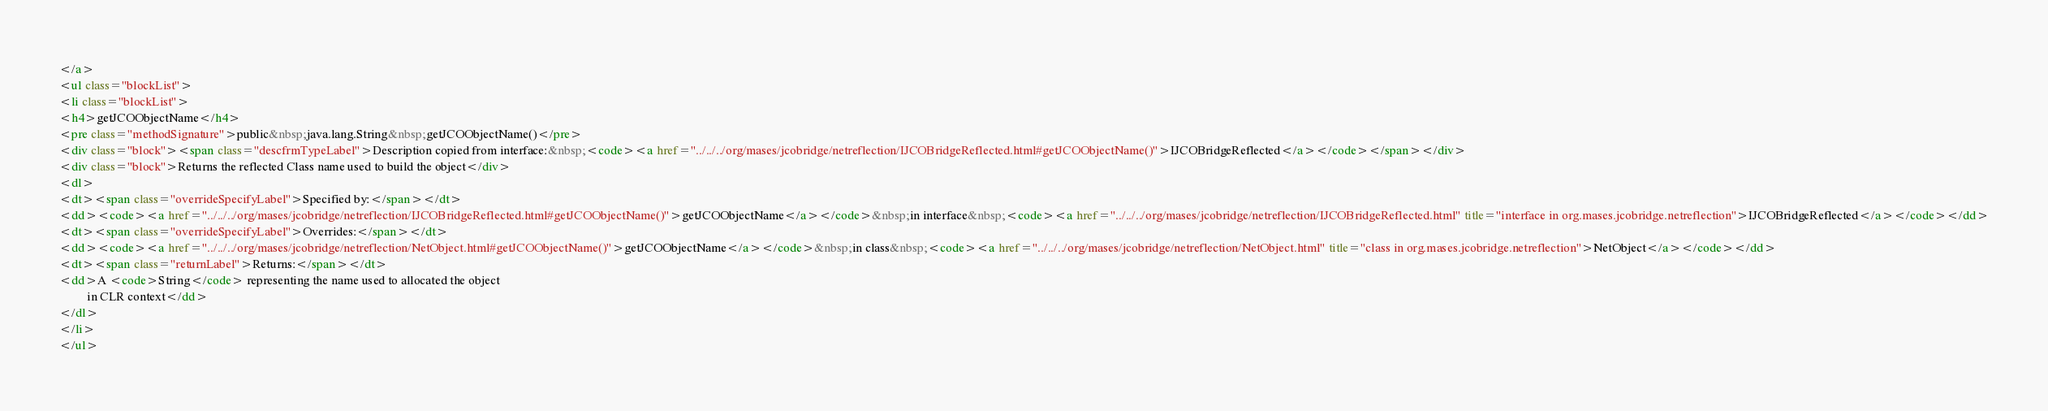<code> <loc_0><loc_0><loc_500><loc_500><_HTML_></a>
<ul class="blockList">
<li class="blockList">
<h4>getJCOObjectName</h4>
<pre class="methodSignature">public&nbsp;java.lang.String&nbsp;getJCOObjectName()</pre>
<div class="block"><span class="descfrmTypeLabel">Description copied from interface:&nbsp;<code><a href="../../../org/mases/jcobridge/netreflection/IJCOBridgeReflected.html#getJCOObjectName()">IJCOBridgeReflected</a></code></span></div>
<div class="block">Returns the reflected Class name used to build the object</div>
<dl>
<dt><span class="overrideSpecifyLabel">Specified by:</span></dt>
<dd><code><a href="../../../org/mases/jcobridge/netreflection/IJCOBridgeReflected.html#getJCOObjectName()">getJCOObjectName</a></code>&nbsp;in interface&nbsp;<code><a href="../../../org/mases/jcobridge/netreflection/IJCOBridgeReflected.html" title="interface in org.mases.jcobridge.netreflection">IJCOBridgeReflected</a></code></dd>
<dt><span class="overrideSpecifyLabel">Overrides:</span></dt>
<dd><code><a href="../../../org/mases/jcobridge/netreflection/NetObject.html#getJCOObjectName()">getJCOObjectName</a></code>&nbsp;in class&nbsp;<code><a href="../../../org/mases/jcobridge/netreflection/NetObject.html" title="class in org.mases.jcobridge.netreflection">NetObject</a></code></dd>
<dt><span class="returnLabel">Returns:</span></dt>
<dd>A <code>String</code> representing the name used to allocated the object
         in CLR context</dd>
</dl>
</li>
</ul></code> 